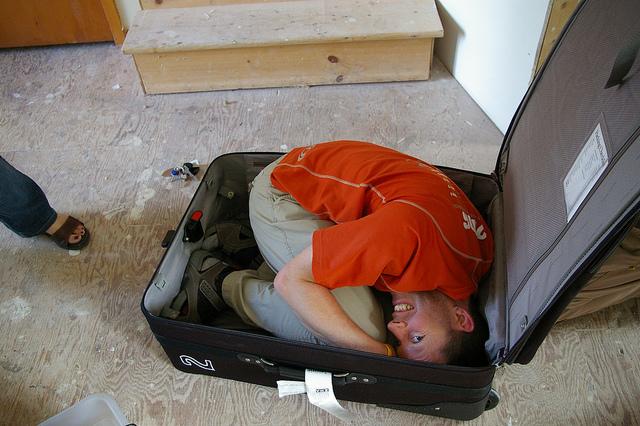Is the floor finished?
Short answer required. No. How many cubic inches is that suitcase?
Write a very short answer. 20. Is the man smiling?
Be succinct. Yes. 